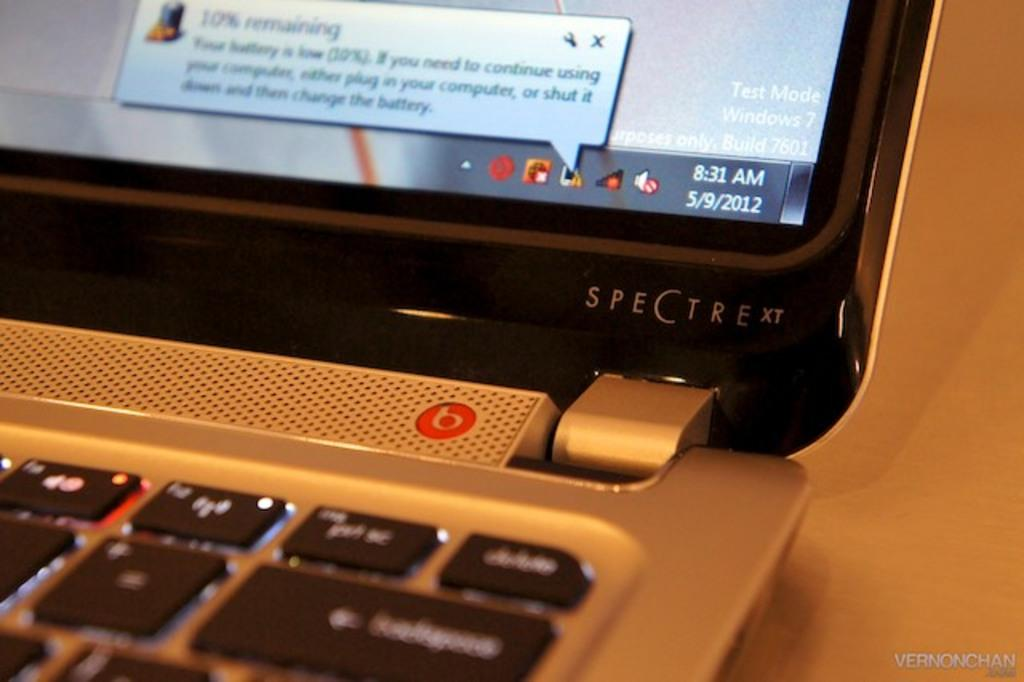<image>
Create a compact narrative representing the image presented. Only a few keys on a Spectre laptop are visible. 